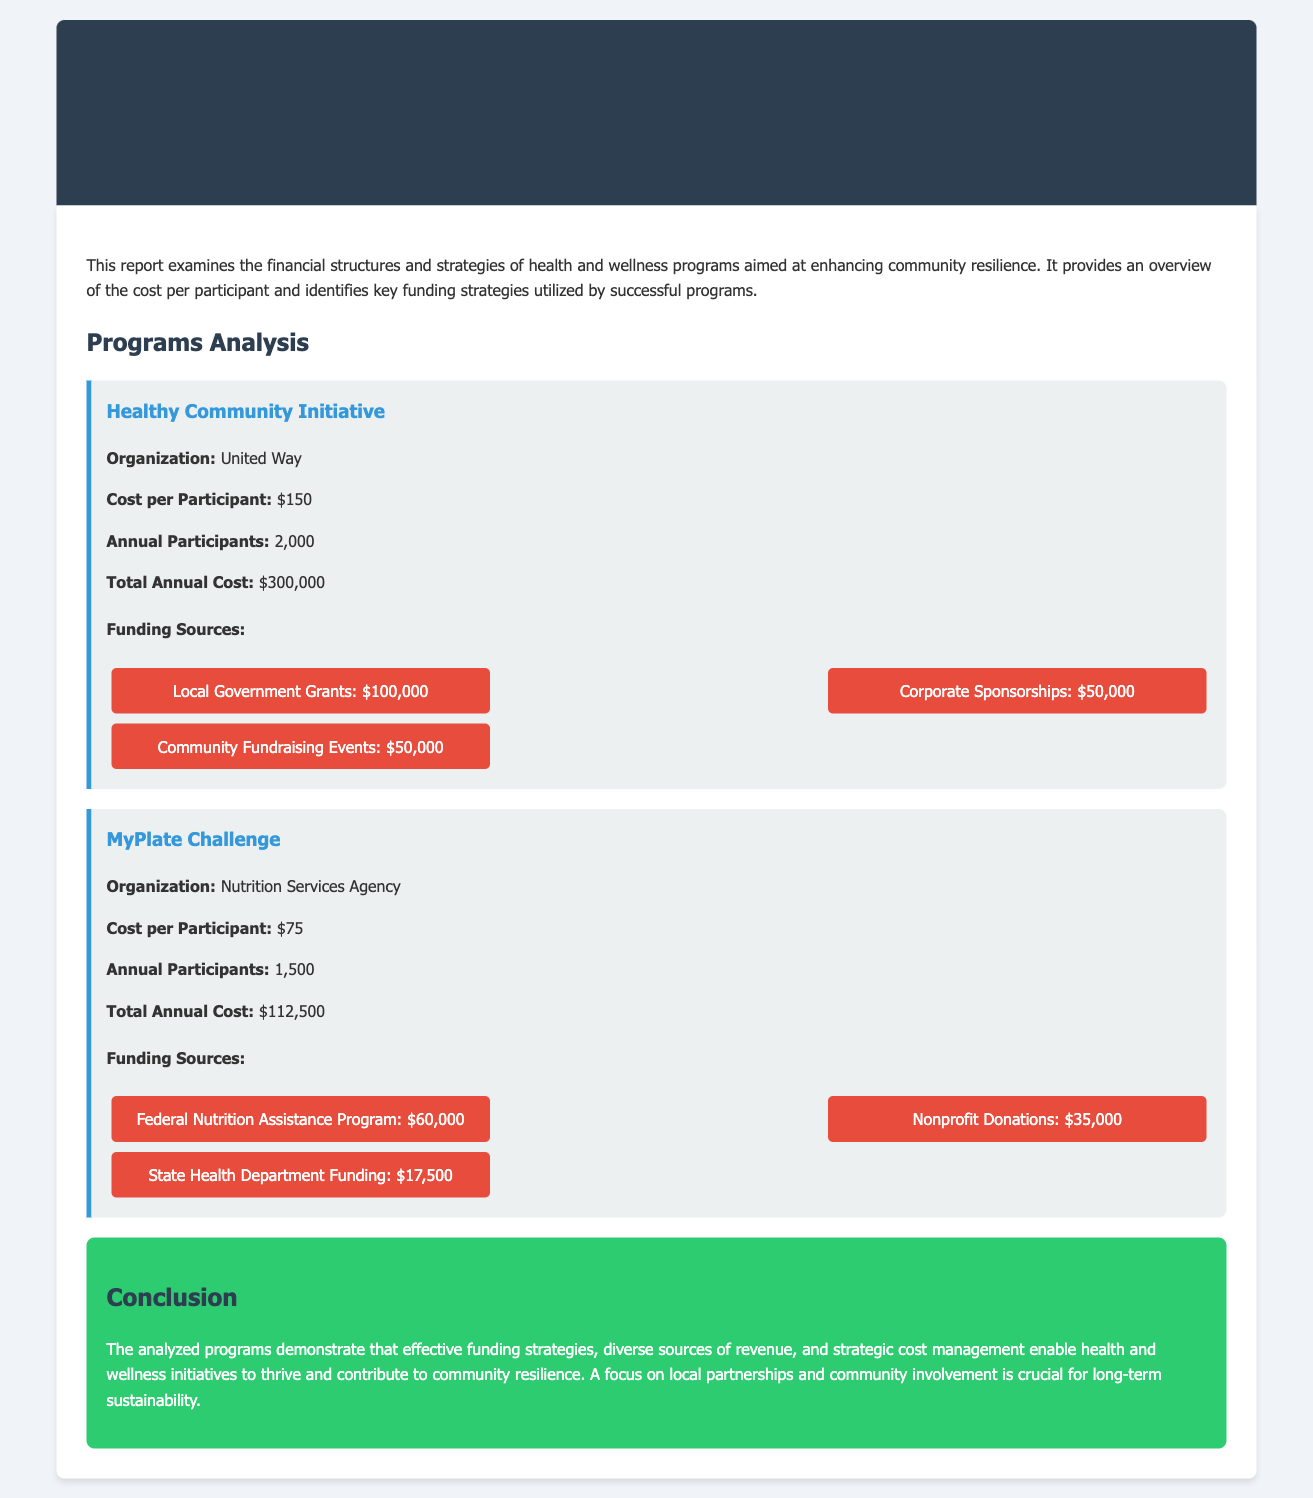what is the cost per participant for the Healthy Community Initiative? The cost per participant for the Healthy Community Initiative is provided in the document.
Answer: $150 how many annual participants are there in the MyPlate Challenge? The document outlines the number of annual participants for each program, specifically for the MyPlate Challenge.
Answer: 1,500 what is the total annual cost for the Healthy Community Initiative? The document presents the total annual cost for the Healthy Community Initiative, which is the product of the cost per participant and the annual participants.
Answer: $300,000 what is the funding source amount for corporate sponsorships in the Healthy Community Initiative? The document lists the different funding sources for the Healthy Community Initiative, highlighting the amount for corporate sponsorships.
Answer: $50,000 which organization runs the MyPlate Challenge? The document identifies the organization responsible for the MyPlate Challenge.
Answer: Nutrition Services Agency how much funding does the Federal Nutrition Assistance Program provide? The document specifies the funding amount from the Federal Nutrition Assistance Program for the MyPlate Challenge.
Answer: $60,000 what is a key aspect for the sustainability of health and wellness programs according to the conclusion? The conclusion remarks on critical elements for the sustainability of health and wellness programs detailed in the report.
Answer: Local partnerships how much funding does community fundraising events contribute to the Healthy Community Initiative? The document indicates the contribution of community fundraising events to the total funding of the Healthy Community Initiative.
Answer: $50,000 what is the total annual cost for the MyPlate Challenge? The total annual cost for the MyPlate Challenge can be calculated from the provided cost per participant and the number of participants mentioned in the document.
Answer: $112,500 